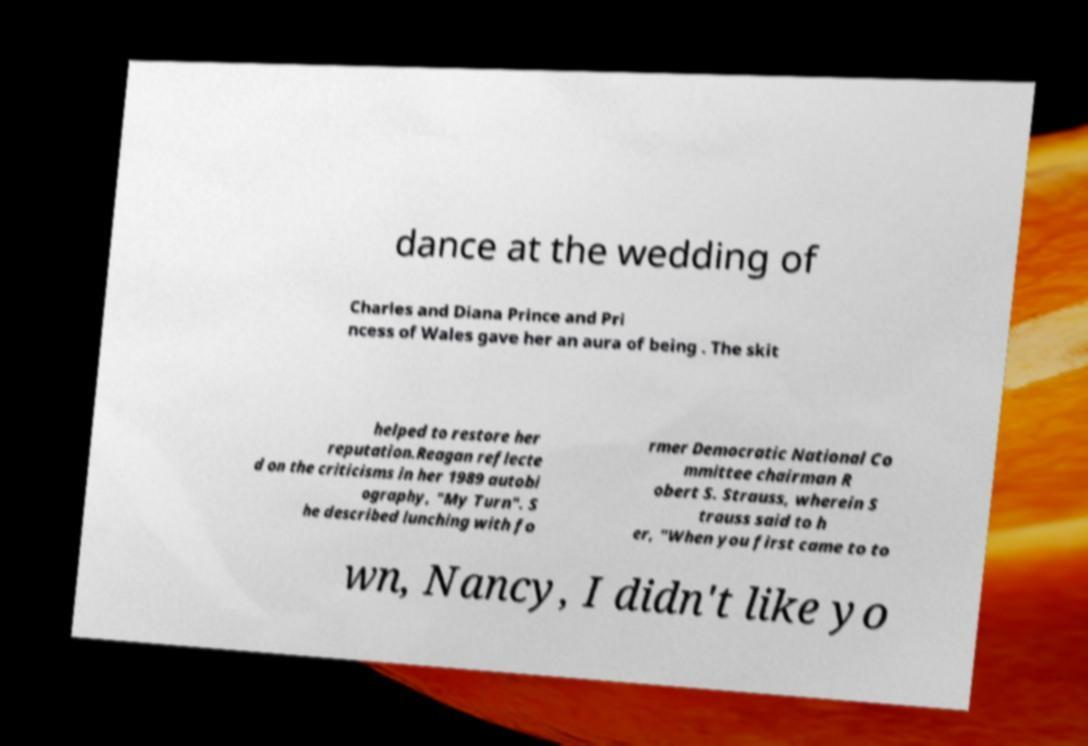Could you assist in decoding the text presented in this image and type it out clearly? dance at the wedding of Charles and Diana Prince and Pri ncess of Wales gave her an aura of being . The skit helped to restore her reputation.Reagan reflecte d on the criticisms in her 1989 autobi ography, "My Turn". S he described lunching with fo rmer Democratic National Co mmittee chairman R obert S. Strauss, wherein S trauss said to h er, "When you first came to to wn, Nancy, I didn't like yo 